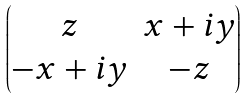Convert formula to latex. <formula><loc_0><loc_0><loc_500><loc_500>\begin{pmatrix} z & x + i y \\ - x + i y & - z \end{pmatrix}</formula> 